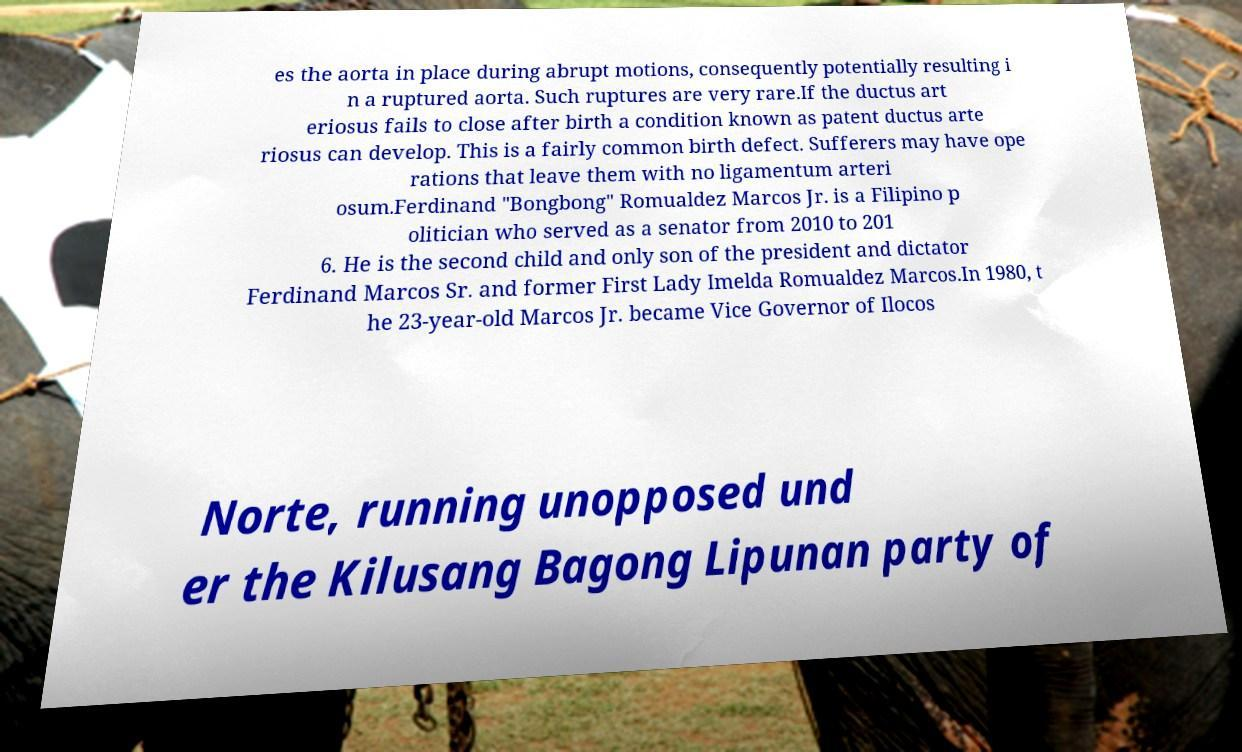Please identify and transcribe the text found in this image. es the aorta in place during abrupt motions, consequently potentially resulting i n a ruptured aorta. Such ruptures are very rare.If the ductus art eriosus fails to close after birth a condition known as patent ductus arte riosus can develop. This is a fairly common birth defect. Sufferers may have ope rations that leave them with no ligamentum arteri osum.Ferdinand "Bongbong" Romualdez Marcos Jr. is a Filipino p olitician who served as a senator from 2010 to 201 6. He is the second child and only son of the president and dictator Ferdinand Marcos Sr. and former First Lady Imelda Romualdez Marcos.In 1980, t he 23-year-old Marcos Jr. became Vice Governor of Ilocos Norte, running unopposed und er the Kilusang Bagong Lipunan party of 